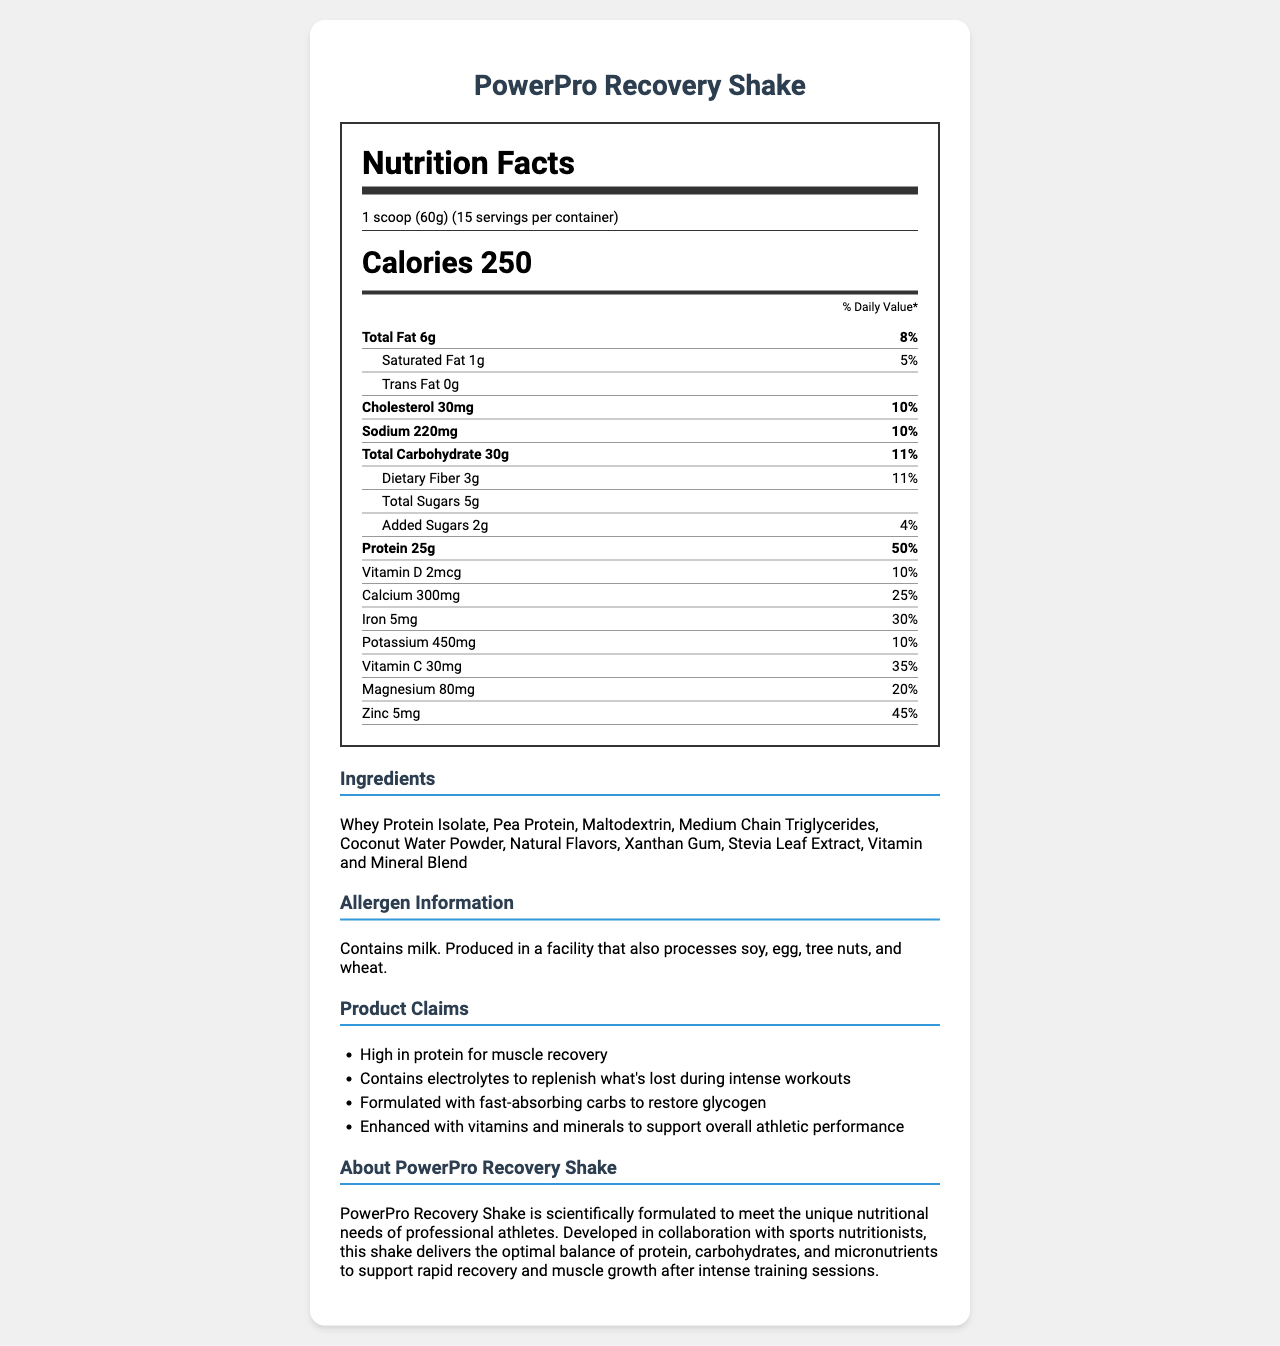what is the serving size of PowerPro Recovery Shake? The serving size is stated as "1 scoop (60g)" in the document.
Answer: 1 scoop (60g) how many calories does one serving contain? According to the document, one serving contains 250 calories.
Answer: 250 how much protein is in one serving? The document indicates that each serving contains 25g of protein.
Answer: 25g which vitamin has the highest daily value percentage? Vitamin C has the highest daily value percentage at 35%.
Answer: Vitamin C what is the brand's claim about electrolytes? The claim statements section includes "Contains electrolytes to replenish what's lost during intense workouts."
Answer: Contains electrolytes to replenish what's lost during intense workouts what type of protein is used in the PowerPro Recovery Shake? The ingredients list includes "Whey Protein Isolate" and "Pea Protein."
Answer: Whey Protein Isolate, Pea Protein what is the daily value percentage for calcium in one serving? The document shows that one serving provides 25% of the daily value for calcium.
Answer: 25% how many servings are there per container? A. 10 B. 15 C. 20 The document specifies there are 15 servings per container.
Answer: B. 15 the total fat content is: A. 3g B. 6g C. 8g The total fat content listed in the document is 6g.
Answer: B. 6g which of the following allergens are processed in the same facility? A. Soy B. Egg C. Tree nuts D. All of the above The allergen information mentions that the product is produced in a facility that processes soy, egg, tree nuts, and wheat.
Answer: D. All of the above is the PowerPro Recovery Shake suitable for vegans? The presence of "Whey Protein Isolate" and the allergen information indicating milk suggest it is not suitable for vegans.
Answer: No which nutrients support muscle recovery and growth according to the claims? The claim statements highlight the high protein content for muscle recovery and fast-absorbing carbs to restore glycogen.
Answer: High protein content and fast-absorbing carbs describe the main idea of the document. The document's main points include the nutritional breakdown per serving, ingredients, allergen warnings, product claims, and brand statement focused on athlete recovery.
Answer: The document provides nutritional information for PowerPro Recovery Shake, highlighting its high protein content for muscle recovery, balanced macronutrient profile, included vitamins and minerals, and allergen information. It is tailored for professional athletes' post-workout recovery needs. what specific vitamins and minerals are included in the shake? The document lists Vitamin D, Calcium, Iron, Potassium, Vitamin C, Magnesium, and Zinc in the nutrition facts section.
Answer: Vitamin D, Calcium, Iron, Potassium, Vitamin C, Magnesium, Zinc what is the source of carbohydrates in the shake? The ingredients list includes "Maltodextrin" which is a source of carbohydrates.
Answer: Maltodextrin how much added sugars does one serving contain? The "Added Sugars" section lists 2g of added sugars per serving.
Answer: 2g how does the document describe the protein content's importance for athletes? One of the claim statements specifically mentions that the product is "High in protein for muscle recovery."
Answer: High in protein for muscle recovery what is the purpose of Coconut Water Powder in the shake? The coconut water powder is likely included to provide electrolytes, as indicated in the claim statements about replenishing electrolytes lost during workouts.
Answer: Contains electrolytes to replenish what's lost during intense workouts does the PowerPro Recovery Shake contain gluten? The document does not specify whether the product contains gluten, although it mentions being produced in a facility that processes wheat.
Answer: Cannot be determined 